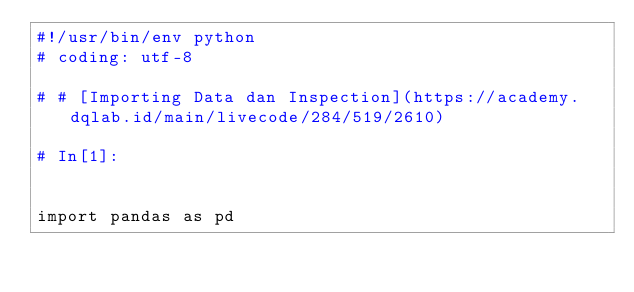<code> <loc_0><loc_0><loc_500><loc_500><_Python_>#!/usr/bin/env python
# coding: utf-8

# # [Importing Data dan Inspection](https://academy.dqlab.id/main/livecode/284/519/2610)

# In[1]:


import pandas as pd
</code> 